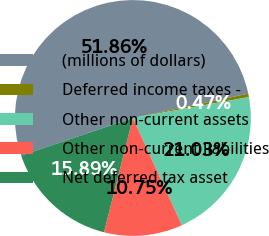Convert chart. <chart><loc_0><loc_0><loc_500><loc_500><pie_chart><fcel>(millions of dollars)<fcel>Deferred income taxes -<fcel>Other non-current assets<fcel>Other non-current liabilities<fcel>Net deferred tax asset<nl><fcel>51.86%<fcel>0.47%<fcel>21.03%<fcel>10.75%<fcel>15.89%<nl></chart> 